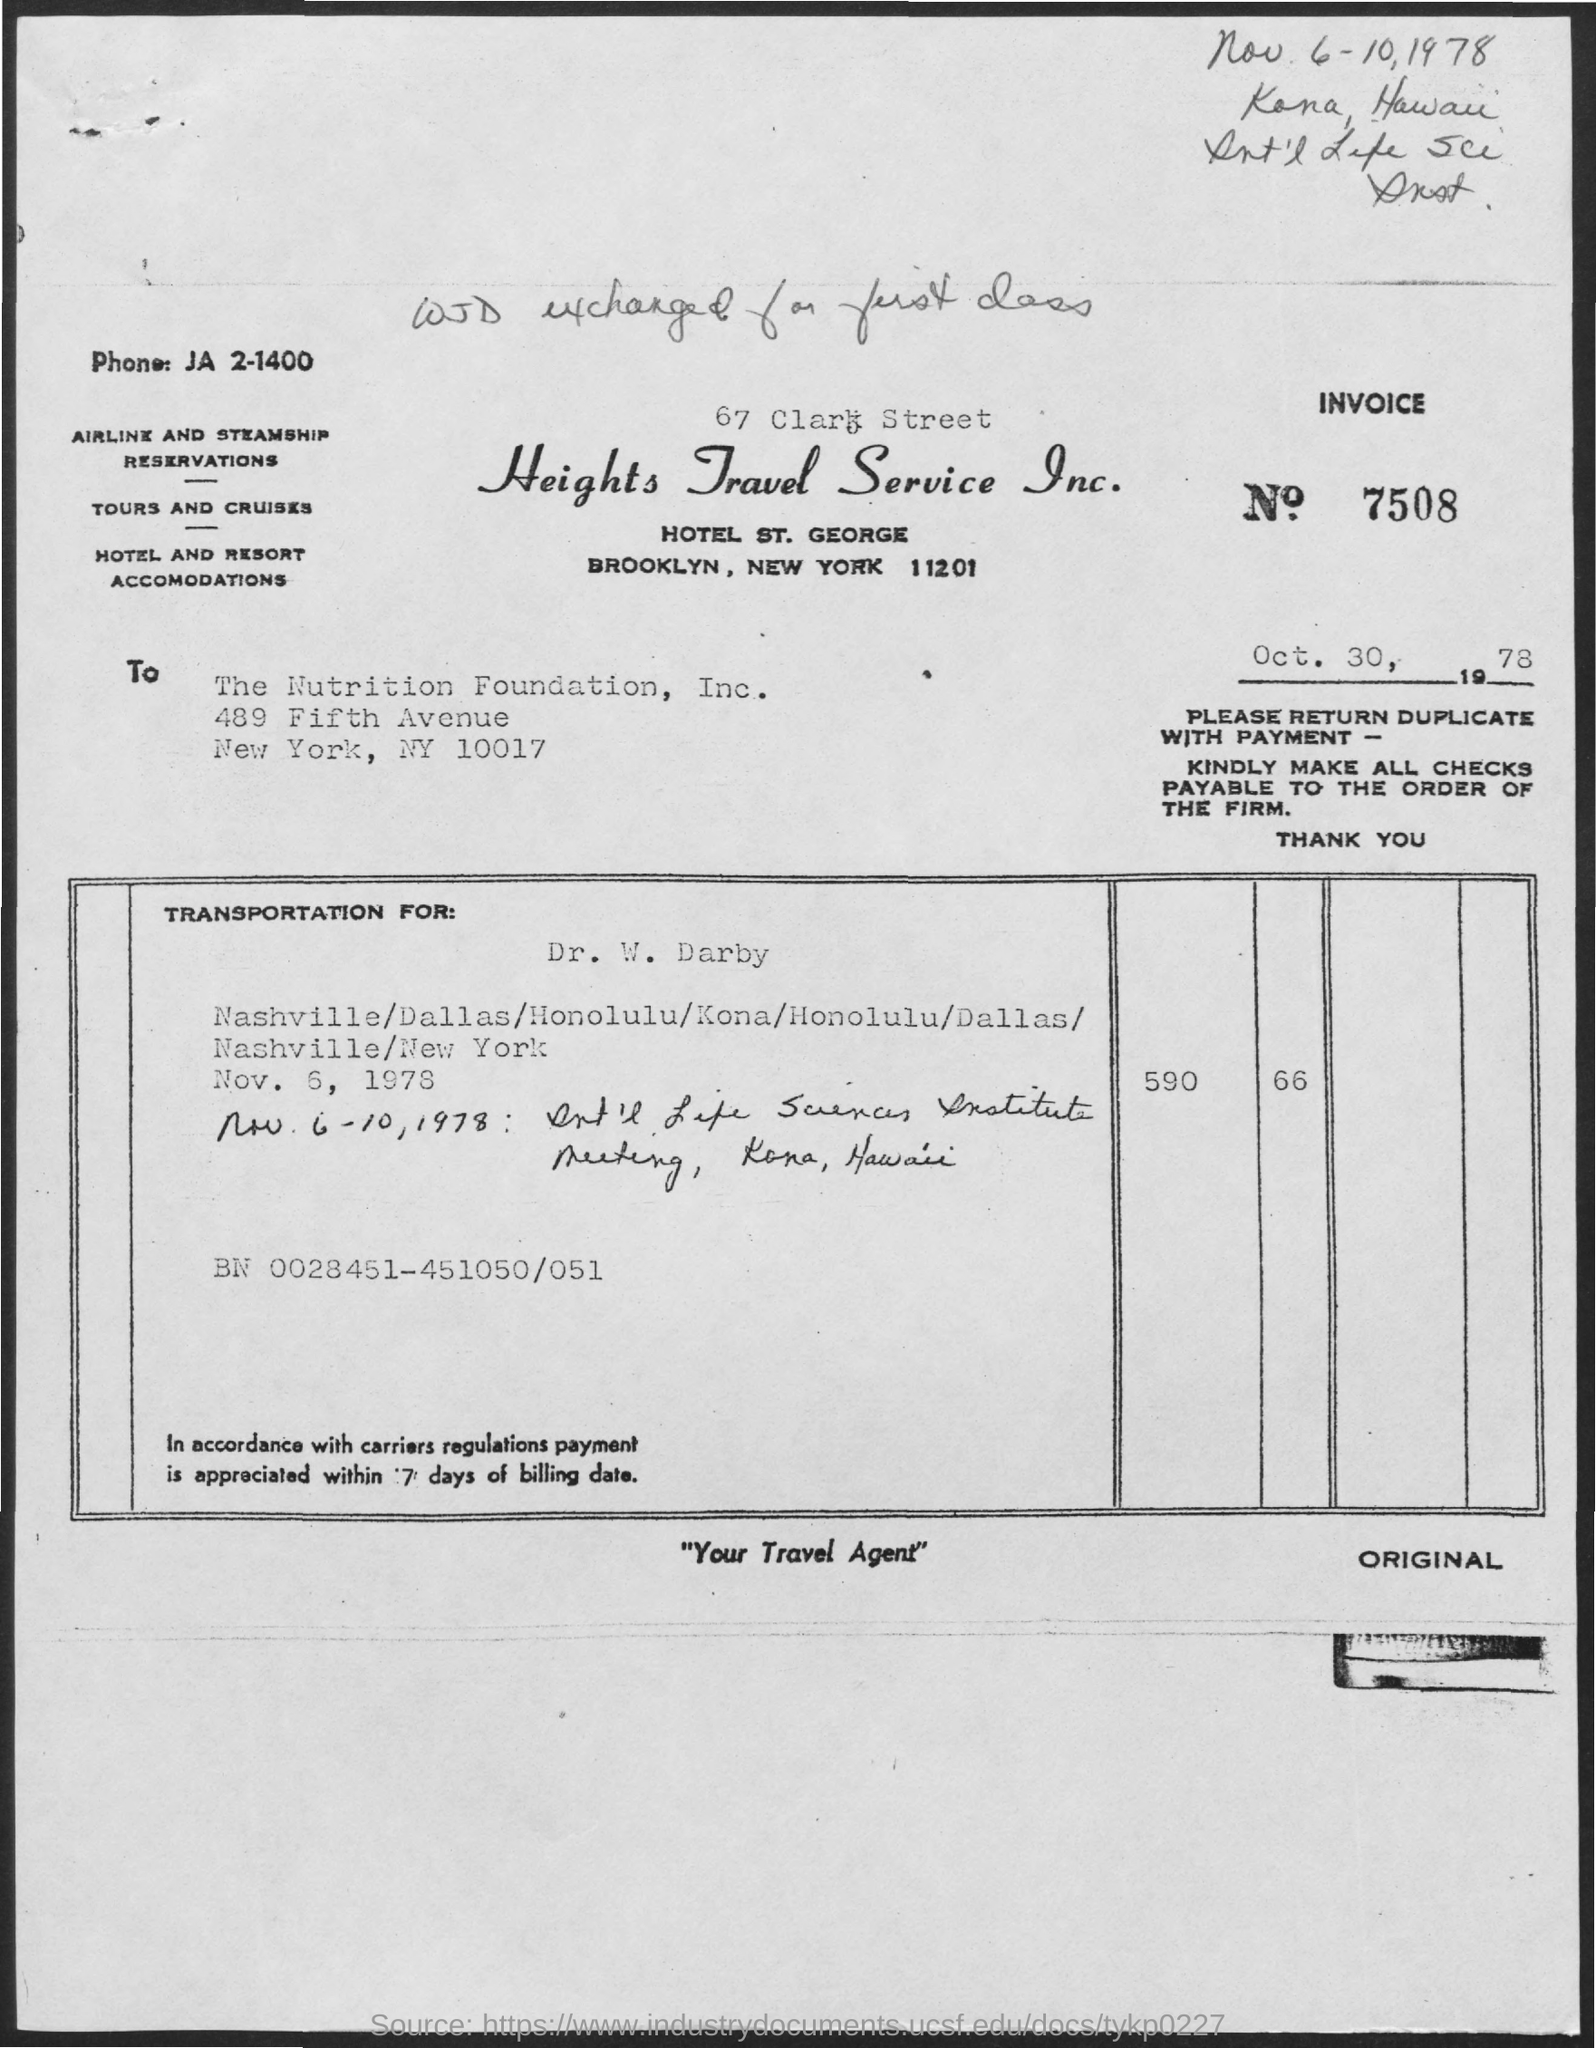Highlight a few significant elements in this photo. The invoice number mentioned in the given form is 7508. The letter was written to the Nutrition Foundation, Inc. The phone number mentioned in the given page is JA 2-1400. 